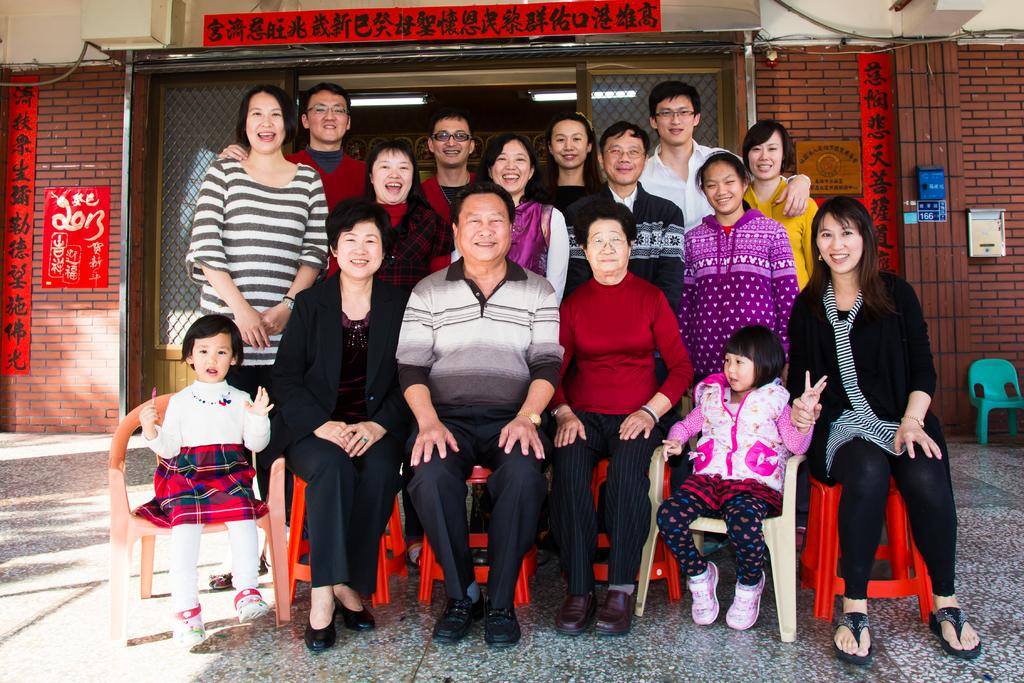How many people are in the image? There is a group of people in the image, but the exact number is not specified. What are the people in the image doing? The people are posing for a camera and smiling. What is the primary surface visible in the image? There is a floor in the image. What type of furniture is present in the image? There is a chair in the image. What can be seen in the background of the image? There is a wall, boards, glasses, and lights in the background of the image. Can you see any grass growing on the floor in the image? No, there is no grass visible on the floor in the image. What type of umbrella is being used by the people in the image? There is no umbrella present in the image. 